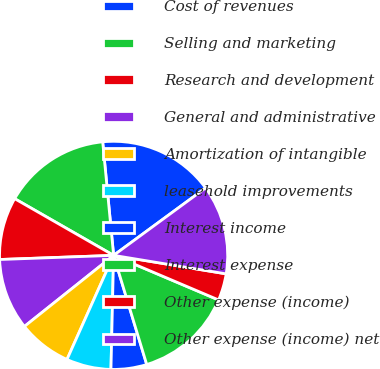Convert chart. <chart><loc_0><loc_0><loc_500><loc_500><pie_chart><fcel>Cost of revenues<fcel>Selling and marketing<fcel>Research and development<fcel>General and administrative<fcel>Amortization of intangible<fcel>leasehold improvements<fcel>Interest income<fcel>Interest expense<fcel>Other expense (income)<fcel>Other expense (income) net<nl><fcel>16.46%<fcel>15.19%<fcel>8.86%<fcel>10.13%<fcel>7.59%<fcel>6.33%<fcel>5.06%<fcel>13.92%<fcel>3.8%<fcel>12.66%<nl></chart> 